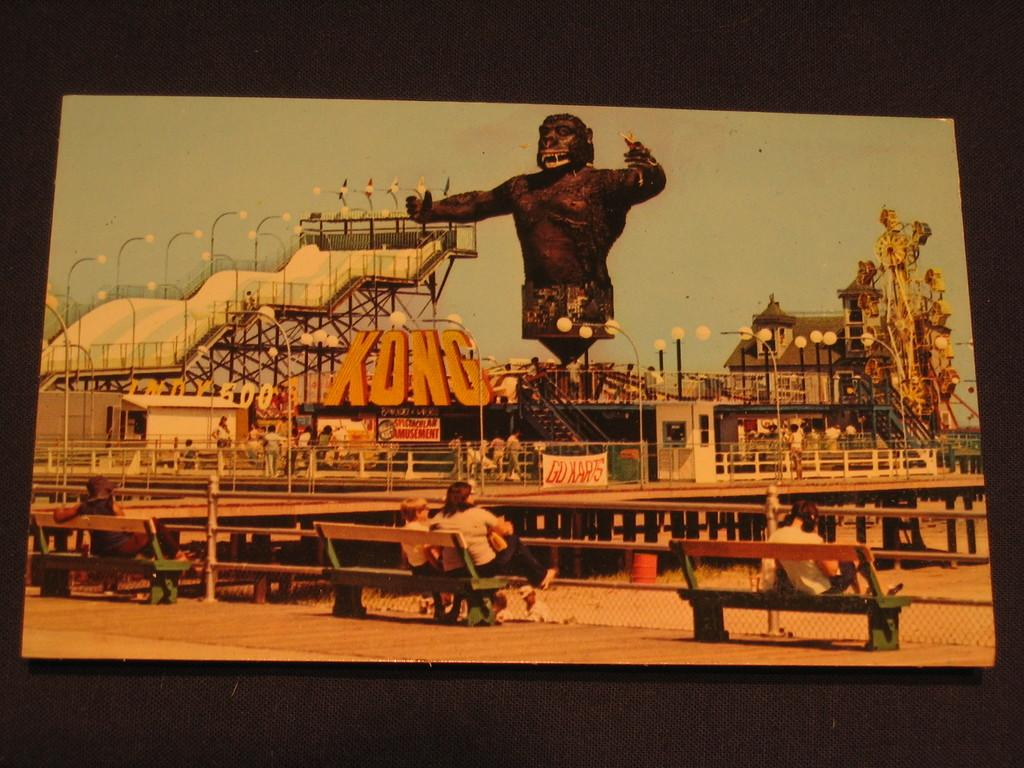Provide a one-sentence caption for the provided image. A picture of a theme park with King Kong and the word "Kong.". 